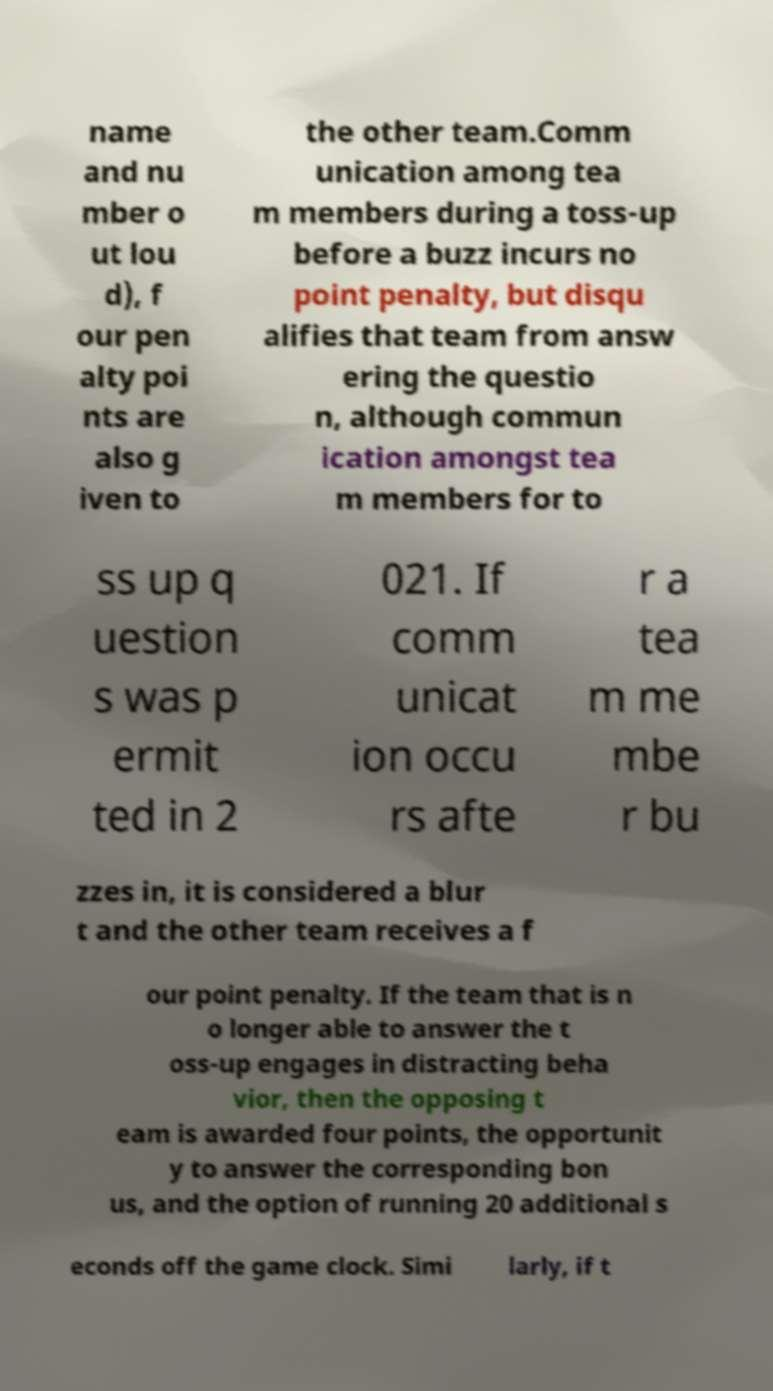Please identify and transcribe the text found in this image. name and nu mber o ut lou d), f our pen alty poi nts are also g iven to the other team.Comm unication among tea m members during a toss-up before a buzz incurs no point penalty, but disqu alifies that team from answ ering the questio n, although commun ication amongst tea m members for to ss up q uestion s was p ermit ted in 2 021. If comm unicat ion occu rs afte r a tea m me mbe r bu zzes in, it is considered a blur t and the other team receives a f our point penalty. If the team that is n o longer able to answer the t oss-up engages in distracting beha vior, then the opposing t eam is awarded four points, the opportunit y to answer the corresponding bon us, and the option of running 20 additional s econds off the game clock. Simi larly, if t 